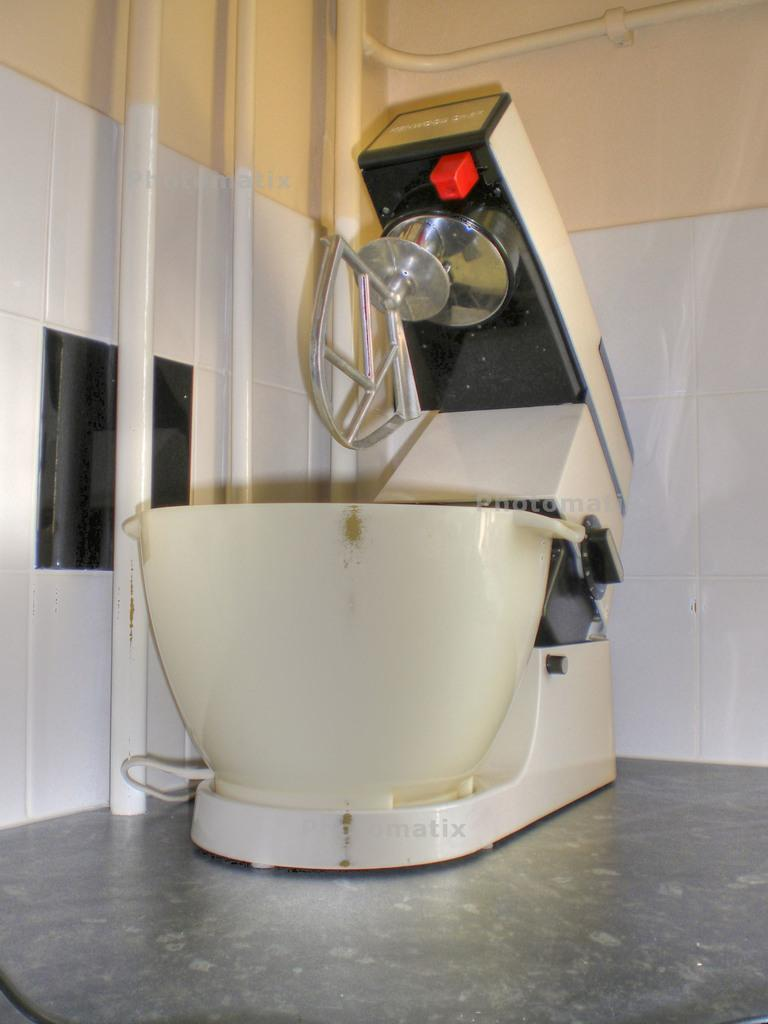What is the main object in the image? There is a machine in the image. Where is the machine located? The machine is on a platform. What can be seen in the background of the image? There are pipes and a wall in the background of the image. What type of scent can be detected coming from the machine in the image? There is no indication of a scent in the image, as it features a machine on a platform with pipes and a wall in the background. 